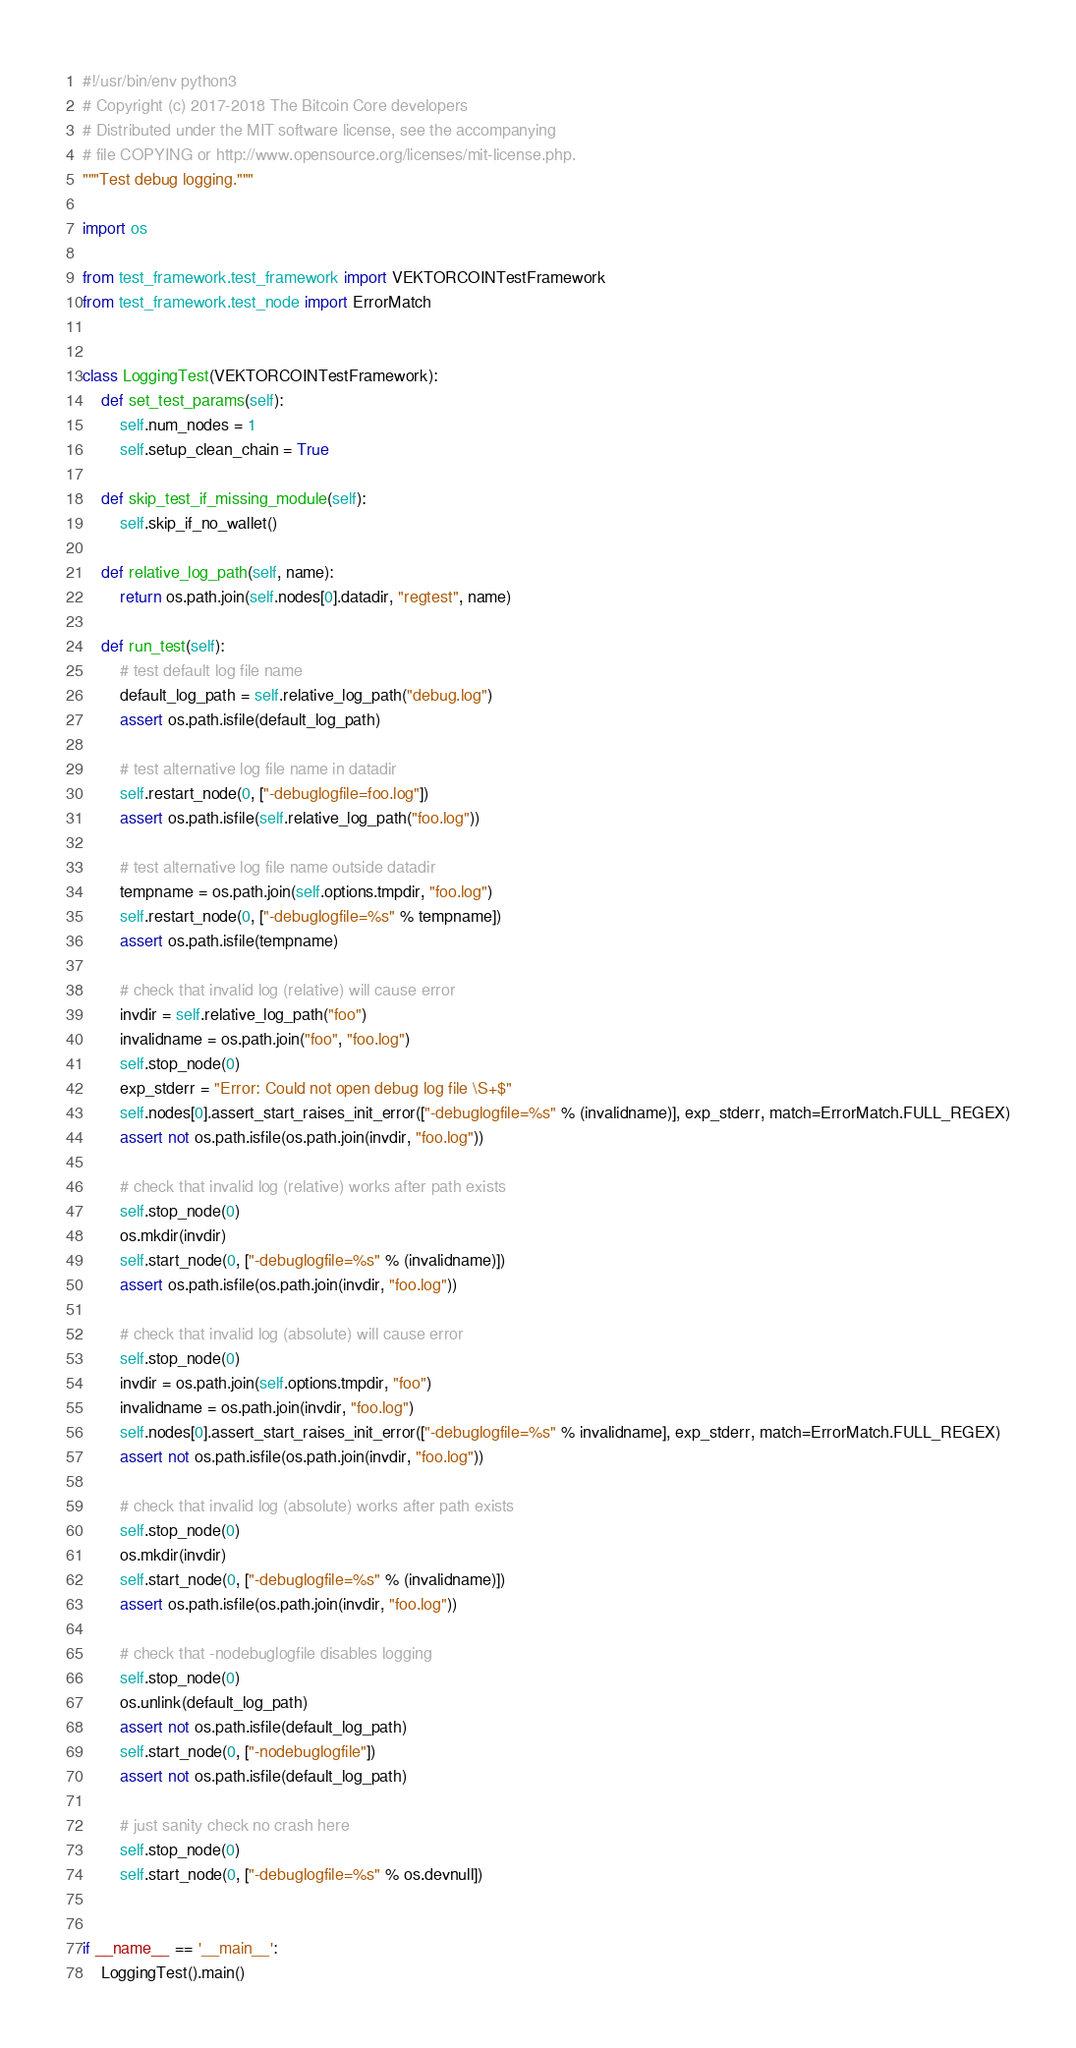Convert code to text. <code><loc_0><loc_0><loc_500><loc_500><_Python_>#!/usr/bin/env python3
# Copyright (c) 2017-2018 The Bitcoin Core developers
# Distributed under the MIT software license, see the accompanying
# file COPYING or http://www.opensource.org/licenses/mit-license.php.
"""Test debug logging."""

import os

from test_framework.test_framework import VEKTORCOINTestFramework
from test_framework.test_node import ErrorMatch


class LoggingTest(VEKTORCOINTestFramework):
    def set_test_params(self):
        self.num_nodes = 1
        self.setup_clean_chain = True

    def skip_test_if_missing_module(self):
        self.skip_if_no_wallet()

    def relative_log_path(self, name):
        return os.path.join(self.nodes[0].datadir, "regtest", name)

    def run_test(self):
        # test default log file name
        default_log_path = self.relative_log_path("debug.log")
        assert os.path.isfile(default_log_path)

        # test alternative log file name in datadir
        self.restart_node(0, ["-debuglogfile=foo.log"])
        assert os.path.isfile(self.relative_log_path("foo.log"))

        # test alternative log file name outside datadir
        tempname = os.path.join(self.options.tmpdir, "foo.log")
        self.restart_node(0, ["-debuglogfile=%s" % tempname])
        assert os.path.isfile(tempname)

        # check that invalid log (relative) will cause error
        invdir = self.relative_log_path("foo")
        invalidname = os.path.join("foo", "foo.log")
        self.stop_node(0)
        exp_stderr = "Error: Could not open debug log file \S+$"
        self.nodes[0].assert_start_raises_init_error(["-debuglogfile=%s" % (invalidname)], exp_stderr, match=ErrorMatch.FULL_REGEX)
        assert not os.path.isfile(os.path.join(invdir, "foo.log"))

        # check that invalid log (relative) works after path exists
        self.stop_node(0)
        os.mkdir(invdir)
        self.start_node(0, ["-debuglogfile=%s" % (invalidname)])
        assert os.path.isfile(os.path.join(invdir, "foo.log"))

        # check that invalid log (absolute) will cause error
        self.stop_node(0)
        invdir = os.path.join(self.options.tmpdir, "foo")
        invalidname = os.path.join(invdir, "foo.log")
        self.nodes[0].assert_start_raises_init_error(["-debuglogfile=%s" % invalidname], exp_stderr, match=ErrorMatch.FULL_REGEX)
        assert not os.path.isfile(os.path.join(invdir, "foo.log"))

        # check that invalid log (absolute) works after path exists
        self.stop_node(0)
        os.mkdir(invdir)
        self.start_node(0, ["-debuglogfile=%s" % (invalidname)])
        assert os.path.isfile(os.path.join(invdir, "foo.log"))

        # check that -nodebuglogfile disables logging
        self.stop_node(0)
        os.unlink(default_log_path)
        assert not os.path.isfile(default_log_path)
        self.start_node(0, ["-nodebuglogfile"])
        assert not os.path.isfile(default_log_path)

        # just sanity check no crash here
        self.stop_node(0)
        self.start_node(0, ["-debuglogfile=%s" % os.devnull])


if __name__ == '__main__':
    LoggingTest().main()
</code> 